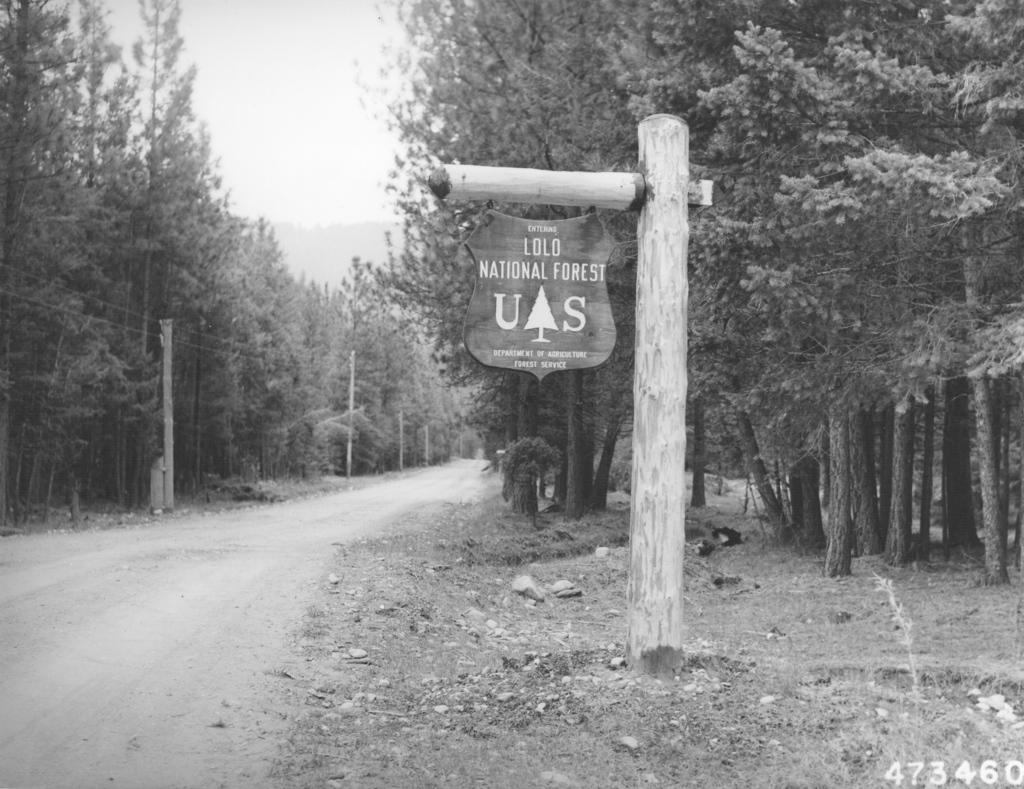What is the main object in the image? There is a board attached to a wooden pole in the image. What can be seen in the background of the image? There are trees and the sky visible in the background of the image. What is the color scheme of the image? The image is in black and white. Can you describe the fight between the sun and the clouds in the image? There is no fight between the sun and the clouds in the image, as the sun is not depicted in the black and white image. 